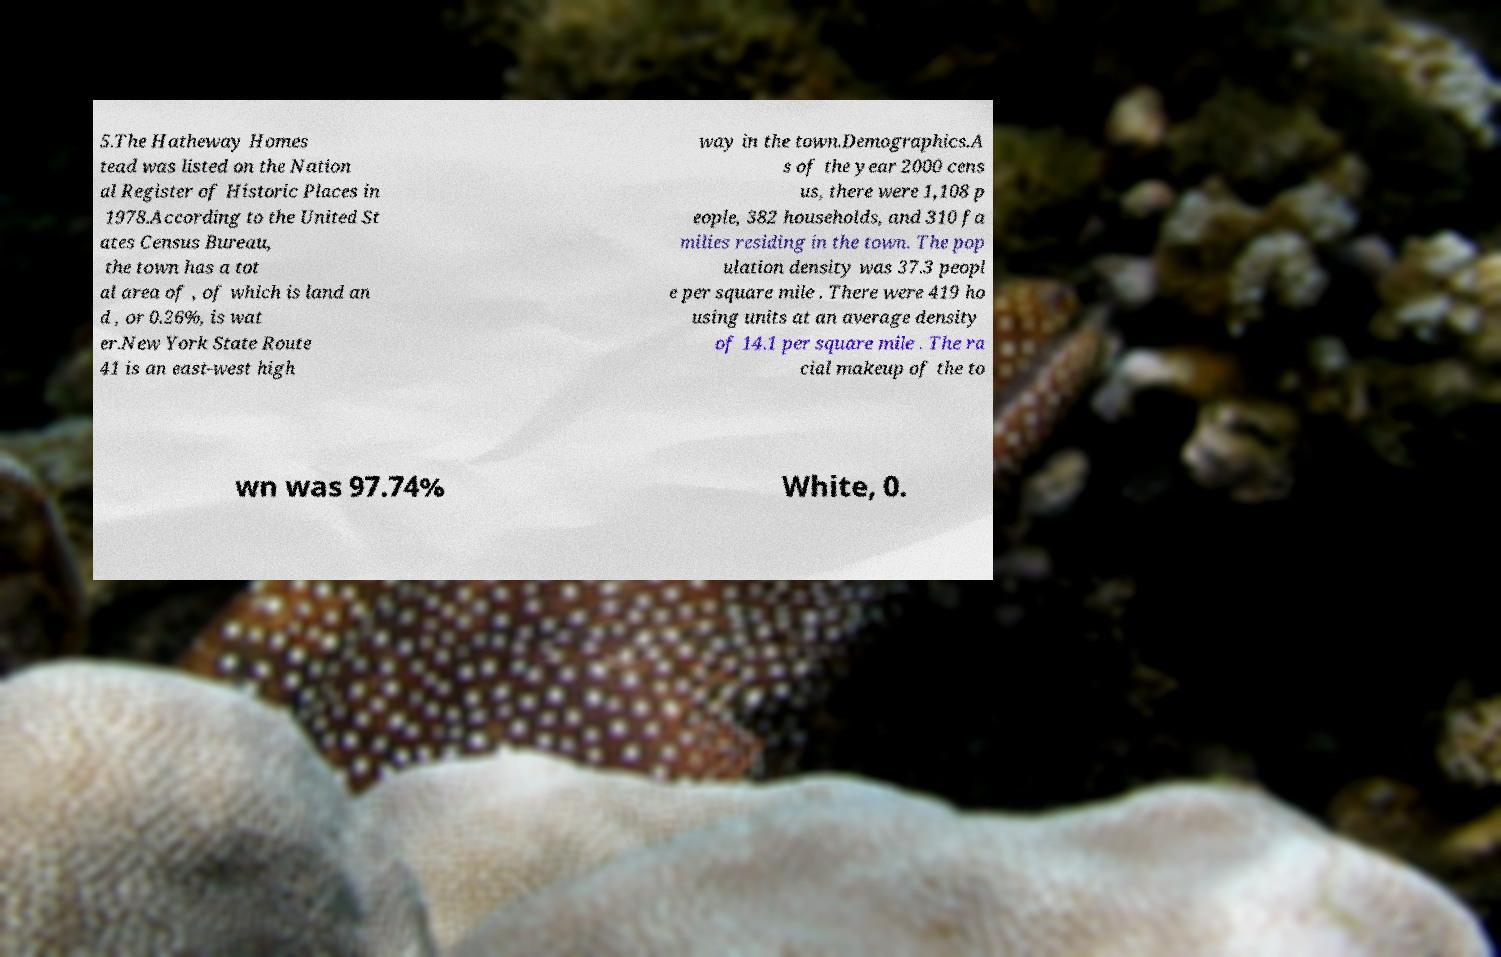Can you read and provide the text displayed in the image?This photo seems to have some interesting text. Can you extract and type it out for me? 5.The Hatheway Homes tead was listed on the Nation al Register of Historic Places in 1978.According to the United St ates Census Bureau, the town has a tot al area of , of which is land an d , or 0.26%, is wat er.New York State Route 41 is an east-west high way in the town.Demographics.A s of the year 2000 cens us, there were 1,108 p eople, 382 households, and 310 fa milies residing in the town. The pop ulation density was 37.3 peopl e per square mile . There were 419 ho using units at an average density of 14.1 per square mile . The ra cial makeup of the to wn was 97.74% White, 0. 